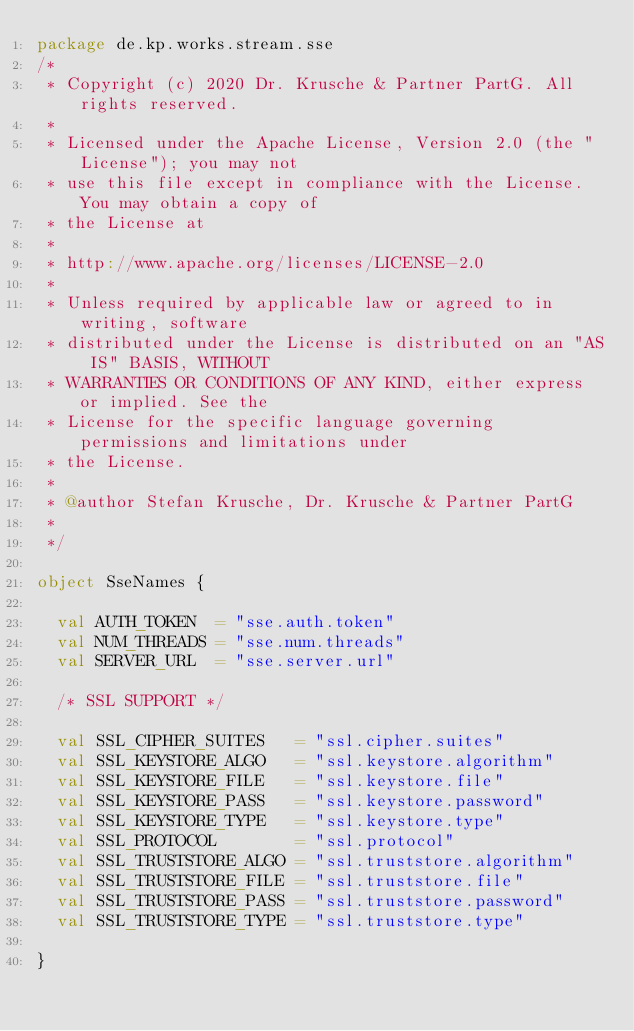<code> <loc_0><loc_0><loc_500><loc_500><_Scala_>package de.kp.works.stream.sse
/*
 * Copyright (c) 2020 Dr. Krusche & Partner PartG. All rights reserved.
 *
 * Licensed under the Apache License, Version 2.0 (the "License"); you may not
 * use this file except in compliance with the License. You may obtain a copy of
 * the License at
 *
 * http://www.apache.org/licenses/LICENSE-2.0
 *
 * Unless required by applicable law or agreed to in writing, software
 * distributed under the License is distributed on an "AS IS" BASIS, WITHOUT
 * WARRANTIES OR CONDITIONS OF ANY KIND, either express or implied. See the
 * License for the specific language governing permissions and limitations under
 * the License.
 *
 * @author Stefan Krusche, Dr. Krusche & Partner PartG
 *
 */

object SseNames {

  val AUTH_TOKEN  = "sse.auth.token"
  val NUM_THREADS = "sse.num.threads"
  val SERVER_URL  = "sse.server.url"

  /* SSL SUPPORT */

  val SSL_CIPHER_SUITES   = "ssl.cipher.suites"
  val SSL_KEYSTORE_ALGO   = "ssl.keystore.algorithm"
  val SSL_KEYSTORE_FILE   = "ssl.keystore.file"
  val SSL_KEYSTORE_PASS   = "ssl.keystore.password"
  val SSL_KEYSTORE_TYPE   = "ssl.keystore.type"
  val SSL_PROTOCOL        = "ssl.protocol"
  val SSL_TRUSTSTORE_ALGO = "ssl.truststore.algorithm"
  val SSL_TRUSTSTORE_FILE = "ssl.truststore.file"
  val SSL_TRUSTSTORE_PASS = "ssl.truststore.password"
  val SSL_TRUSTSTORE_TYPE = "ssl.truststore.type"

}
</code> 